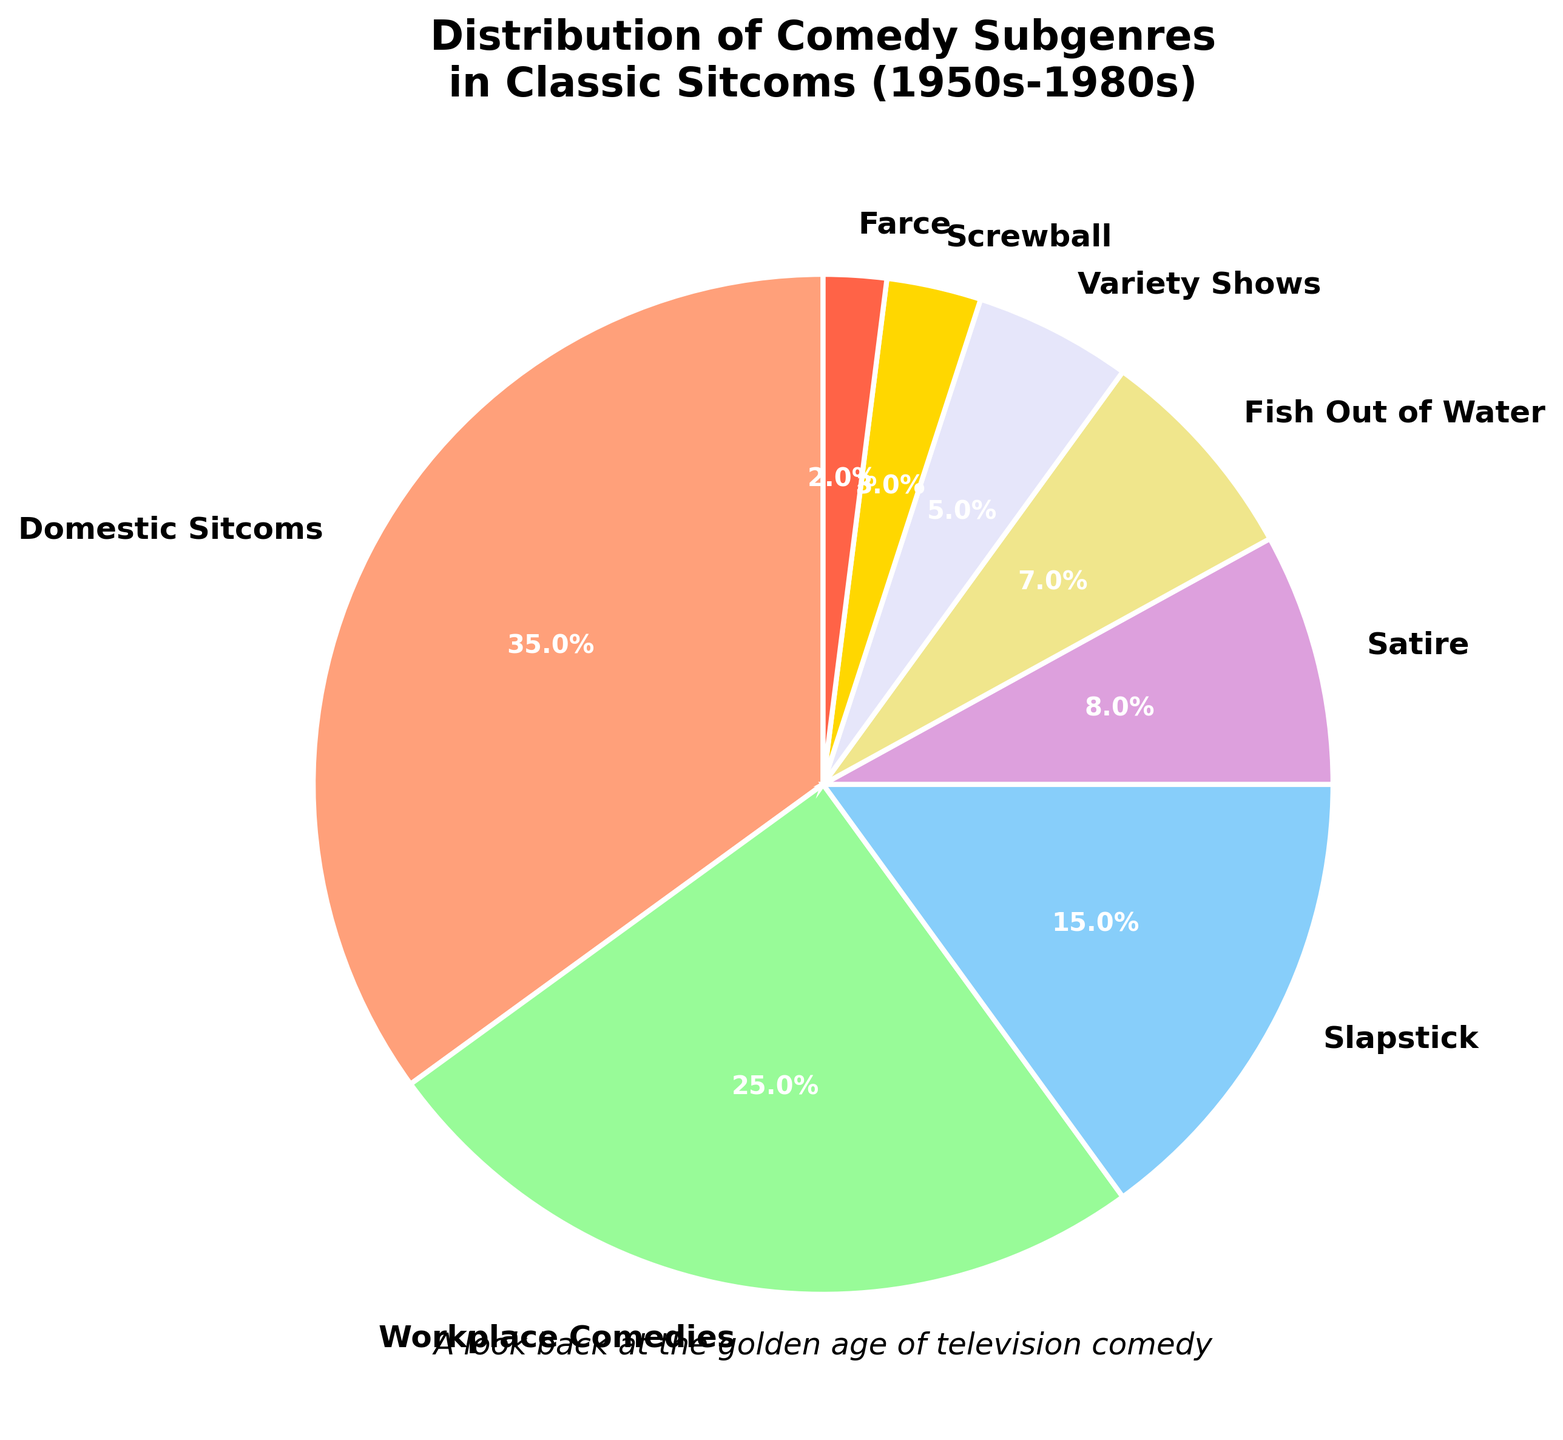What is the most common subgenre in classic sitcoms according to the pie chart? The pie chart shows that Domestic Sitcoms occupy the largest portion.
Answer: Domestic Sitcoms Which two subgenres have the smallest percentages? By looking at the smallest slices, we see Farce at 2% and Screwball at 3%.
Answer: Farce and Screwball What percentage is occupied by Satire and Fish Out of Water combined? Adding the percentages of Satire (8%) and Fish Out of Water (7%), we get 15%.
Answer: 15% Is the percentage of Domestic Sitcoms greater than the combined percentage of Satire and Fish Out of Water? Domestic Sitcoms are 35%, whereas Satire and Fish Out of Water combined are 15%. Since 35% > 15%, the answer is yes.
Answer: Yes How much larger is the percentage of Workplace Comedies compared to Variety Shows? The percentage of Workplace Comedies is 25%, and that of Variety Shows is 5%. The difference is 25% - 5% = 20%.
Answer: 20% What is the total percentage of subgenres that individually occupy less than 10%? Adding the percentages of Satire (8%), Fish Out of Water (7%), Variety Shows (5%), Screwball (3%), and Farce (2%), we get 8% + 7% + 5% + 3% + 2% = 25%.
Answer: 25% Which subgenre has a visual attribute with the color red in the pie chart? The color red is used to represent Domestic Sitcoms in the pie chart.
Answer: Domestic Sitcoms Is the percentage of Slapstick closer to the percentage of Workplace Comedies or Variety Shows? The percentage of Slapstick is 15%. It's closer to Workplace Comedies (25%) than to Variety Shows (5%) because the absolute difference is smaller (10% vs. 10%).
Answer: Workplace Comedies Compare the combined percentage of Farce and Screwball with that of Satire. Which is larger? The combined percentage of Farce (2%) and Screwball (3%) is 2% + 3% = 5%, which is smaller than Satire's 8%.
Answer: Satire What is the visual indicator of the most common subgenre? The slice representing Domestic Sitcoms is the largest in the pie chart.
Answer: The largest slice 